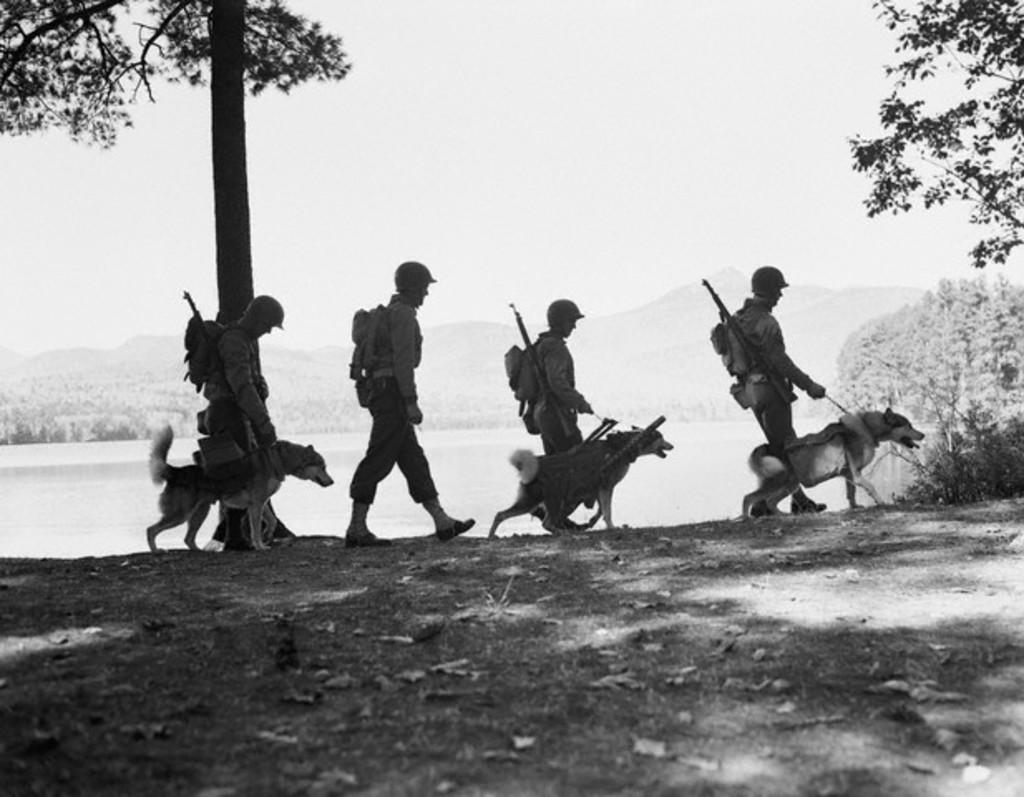What can be seen in the background of the image? There is a sky in the image. What type of vegetation is present in the image? There are trees in the image. What are the people in the image doing? There are people walking in the image. How many dogs are in the image? There are three dogs in the image. What type of cloth is being used to cover the earth in the image? There is no cloth covering the earth in the image, as the image does not depict the earth. 